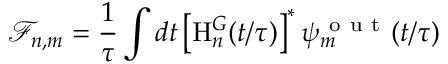<formula> <loc_0><loc_0><loc_500><loc_500>\mathcal { F } _ { n , m } = \frac { 1 } { \tau } \int d t \left [ H _ { n } ^ { G } ( t / \tau ) \right ] ^ { * } \psi _ { m } ^ { o u t } ( t / \tau )</formula> 